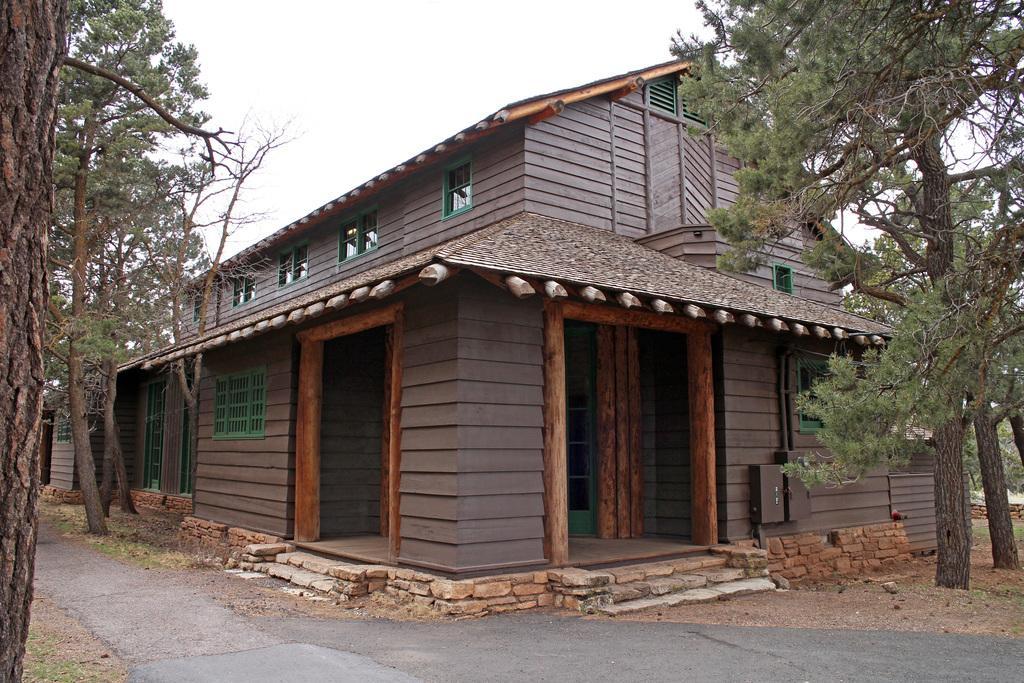Describe this image in one or two sentences. In this picture I can see the road. I can see the house. I can see trees on the left and right side. I can see clouds in the sky. 